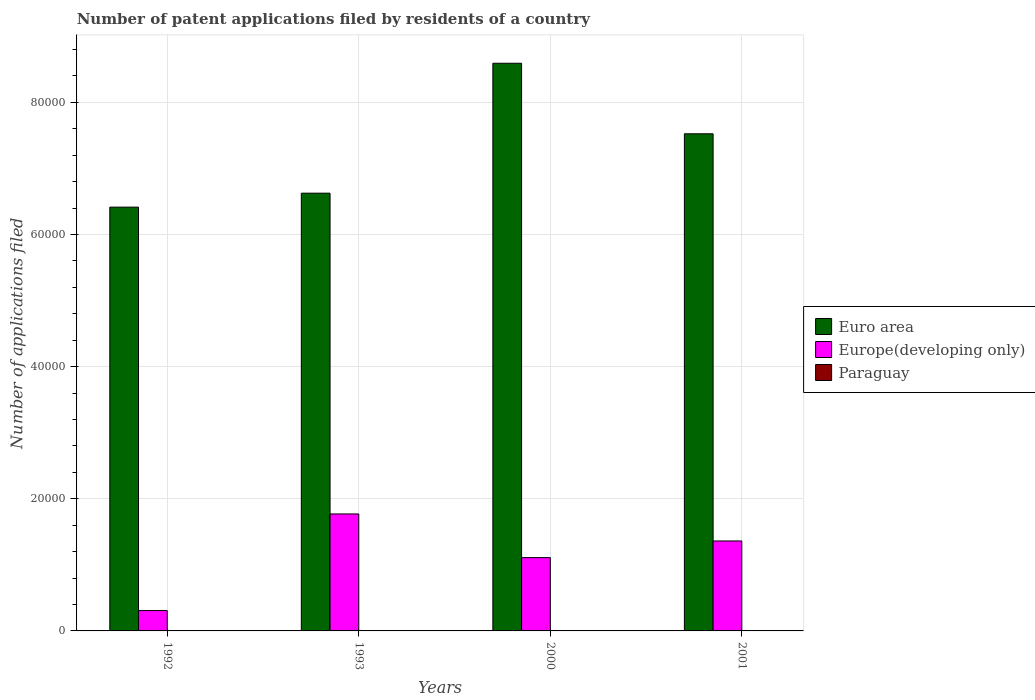How many groups of bars are there?
Offer a very short reply. 4. Are the number of bars per tick equal to the number of legend labels?
Your answer should be very brief. Yes. Are the number of bars on each tick of the X-axis equal?
Keep it short and to the point. Yes. How many bars are there on the 2nd tick from the right?
Keep it short and to the point. 3. In how many cases, is the number of bars for a given year not equal to the number of legend labels?
Keep it short and to the point. 0. Across all years, what is the maximum number of applications filed in Europe(developing only)?
Make the answer very short. 1.77e+04. Across all years, what is the minimum number of applications filed in Europe(developing only)?
Your answer should be compact. 3082. In which year was the number of applications filed in Paraguay minimum?
Provide a succinct answer. 2000. What is the total number of applications filed in Euro area in the graph?
Offer a terse response. 2.92e+05. What is the difference between the number of applications filed in Europe(developing only) in 1992 and that in 1993?
Your response must be concise. -1.46e+04. What is the difference between the number of applications filed in Paraguay in 1992 and the number of applications filed in Euro area in 2001?
Keep it short and to the point. -7.52e+04. What is the average number of applications filed in Europe(developing only) per year?
Your answer should be compact. 1.14e+04. In the year 2000, what is the difference between the number of applications filed in Europe(developing only) and number of applications filed in Paraguay?
Give a very brief answer. 1.11e+04. In how many years, is the number of applications filed in Europe(developing only) greater than 8000?
Provide a succinct answer. 3. What is the ratio of the number of applications filed in Paraguay in 1993 to that in 2000?
Make the answer very short. 2.73. Is the difference between the number of applications filed in Europe(developing only) in 1993 and 2001 greater than the difference between the number of applications filed in Paraguay in 1993 and 2001?
Provide a short and direct response. Yes. What is the difference between the highest and the second highest number of applications filed in Euro area?
Ensure brevity in your answer.  1.07e+04. What is the difference between the highest and the lowest number of applications filed in Euro area?
Keep it short and to the point. 2.18e+04. What does the 3rd bar from the left in 1992 represents?
Make the answer very short. Paraguay. What does the 2nd bar from the right in 2001 represents?
Keep it short and to the point. Europe(developing only). Is it the case that in every year, the sum of the number of applications filed in Paraguay and number of applications filed in Euro area is greater than the number of applications filed in Europe(developing only)?
Your answer should be very brief. Yes. How many bars are there?
Your answer should be compact. 12. Are all the bars in the graph horizontal?
Ensure brevity in your answer.  No. How many years are there in the graph?
Ensure brevity in your answer.  4. What is the difference between two consecutive major ticks on the Y-axis?
Provide a succinct answer. 2.00e+04. Are the values on the major ticks of Y-axis written in scientific E-notation?
Make the answer very short. No. Does the graph contain grids?
Offer a very short reply. Yes. How are the legend labels stacked?
Offer a terse response. Vertical. What is the title of the graph?
Your response must be concise. Number of patent applications filed by residents of a country. What is the label or title of the Y-axis?
Offer a terse response. Number of applications filed. What is the Number of applications filed of Euro area in 1992?
Ensure brevity in your answer.  6.41e+04. What is the Number of applications filed in Europe(developing only) in 1992?
Keep it short and to the point. 3082. What is the Number of applications filed of Paraguay in 1992?
Your response must be concise. 20. What is the Number of applications filed in Euro area in 1993?
Your answer should be compact. 6.63e+04. What is the Number of applications filed of Europe(developing only) in 1993?
Your answer should be compact. 1.77e+04. What is the Number of applications filed of Euro area in 2000?
Provide a succinct answer. 8.59e+04. What is the Number of applications filed in Europe(developing only) in 2000?
Offer a terse response. 1.11e+04. What is the Number of applications filed of Euro area in 2001?
Offer a very short reply. 7.52e+04. What is the Number of applications filed of Europe(developing only) in 2001?
Provide a succinct answer. 1.36e+04. What is the Number of applications filed of Paraguay in 2001?
Offer a very short reply. 12. Across all years, what is the maximum Number of applications filed in Euro area?
Provide a succinct answer. 8.59e+04. Across all years, what is the maximum Number of applications filed of Europe(developing only)?
Your answer should be very brief. 1.77e+04. Across all years, what is the minimum Number of applications filed in Euro area?
Your answer should be very brief. 6.41e+04. Across all years, what is the minimum Number of applications filed of Europe(developing only)?
Your answer should be compact. 3082. What is the total Number of applications filed of Euro area in the graph?
Offer a terse response. 2.92e+05. What is the total Number of applications filed in Europe(developing only) in the graph?
Ensure brevity in your answer.  4.55e+04. What is the difference between the Number of applications filed of Euro area in 1992 and that in 1993?
Your answer should be very brief. -2111. What is the difference between the Number of applications filed of Europe(developing only) in 1992 and that in 1993?
Make the answer very short. -1.46e+04. What is the difference between the Number of applications filed in Euro area in 1992 and that in 2000?
Your response must be concise. -2.18e+04. What is the difference between the Number of applications filed of Europe(developing only) in 1992 and that in 2000?
Offer a terse response. -8015. What is the difference between the Number of applications filed in Euro area in 1992 and that in 2001?
Your answer should be very brief. -1.11e+04. What is the difference between the Number of applications filed of Europe(developing only) in 1992 and that in 2001?
Offer a terse response. -1.05e+04. What is the difference between the Number of applications filed in Euro area in 1993 and that in 2000?
Ensure brevity in your answer.  -1.97e+04. What is the difference between the Number of applications filed of Europe(developing only) in 1993 and that in 2000?
Offer a terse response. 6608. What is the difference between the Number of applications filed in Euro area in 1993 and that in 2001?
Your response must be concise. -8989. What is the difference between the Number of applications filed of Europe(developing only) in 1993 and that in 2001?
Your answer should be compact. 4090. What is the difference between the Number of applications filed in Euro area in 2000 and that in 2001?
Offer a terse response. 1.07e+04. What is the difference between the Number of applications filed of Europe(developing only) in 2000 and that in 2001?
Your response must be concise. -2518. What is the difference between the Number of applications filed of Paraguay in 2000 and that in 2001?
Give a very brief answer. -1. What is the difference between the Number of applications filed in Euro area in 1992 and the Number of applications filed in Europe(developing only) in 1993?
Provide a succinct answer. 4.64e+04. What is the difference between the Number of applications filed of Euro area in 1992 and the Number of applications filed of Paraguay in 1993?
Your answer should be very brief. 6.41e+04. What is the difference between the Number of applications filed in Europe(developing only) in 1992 and the Number of applications filed in Paraguay in 1993?
Provide a succinct answer. 3052. What is the difference between the Number of applications filed in Euro area in 1992 and the Number of applications filed in Europe(developing only) in 2000?
Offer a very short reply. 5.30e+04. What is the difference between the Number of applications filed in Euro area in 1992 and the Number of applications filed in Paraguay in 2000?
Your response must be concise. 6.41e+04. What is the difference between the Number of applications filed of Europe(developing only) in 1992 and the Number of applications filed of Paraguay in 2000?
Your answer should be compact. 3071. What is the difference between the Number of applications filed in Euro area in 1992 and the Number of applications filed in Europe(developing only) in 2001?
Give a very brief answer. 5.05e+04. What is the difference between the Number of applications filed in Euro area in 1992 and the Number of applications filed in Paraguay in 2001?
Your answer should be very brief. 6.41e+04. What is the difference between the Number of applications filed in Europe(developing only) in 1992 and the Number of applications filed in Paraguay in 2001?
Keep it short and to the point. 3070. What is the difference between the Number of applications filed of Euro area in 1993 and the Number of applications filed of Europe(developing only) in 2000?
Provide a succinct answer. 5.52e+04. What is the difference between the Number of applications filed of Euro area in 1993 and the Number of applications filed of Paraguay in 2000?
Provide a succinct answer. 6.62e+04. What is the difference between the Number of applications filed in Europe(developing only) in 1993 and the Number of applications filed in Paraguay in 2000?
Your response must be concise. 1.77e+04. What is the difference between the Number of applications filed in Euro area in 1993 and the Number of applications filed in Europe(developing only) in 2001?
Offer a terse response. 5.26e+04. What is the difference between the Number of applications filed of Euro area in 1993 and the Number of applications filed of Paraguay in 2001?
Provide a short and direct response. 6.62e+04. What is the difference between the Number of applications filed in Europe(developing only) in 1993 and the Number of applications filed in Paraguay in 2001?
Make the answer very short. 1.77e+04. What is the difference between the Number of applications filed of Euro area in 2000 and the Number of applications filed of Europe(developing only) in 2001?
Offer a very short reply. 7.23e+04. What is the difference between the Number of applications filed in Euro area in 2000 and the Number of applications filed in Paraguay in 2001?
Keep it short and to the point. 8.59e+04. What is the difference between the Number of applications filed of Europe(developing only) in 2000 and the Number of applications filed of Paraguay in 2001?
Your response must be concise. 1.11e+04. What is the average Number of applications filed of Euro area per year?
Provide a short and direct response. 7.29e+04. What is the average Number of applications filed of Europe(developing only) per year?
Offer a terse response. 1.14e+04. What is the average Number of applications filed in Paraguay per year?
Your response must be concise. 18.25. In the year 1992, what is the difference between the Number of applications filed of Euro area and Number of applications filed of Europe(developing only)?
Provide a succinct answer. 6.11e+04. In the year 1992, what is the difference between the Number of applications filed in Euro area and Number of applications filed in Paraguay?
Provide a succinct answer. 6.41e+04. In the year 1992, what is the difference between the Number of applications filed of Europe(developing only) and Number of applications filed of Paraguay?
Offer a terse response. 3062. In the year 1993, what is the difference between the Number of applications filed of Euro area and Number of applications filed of Europe(developing only)?
Ensure brevity in your answer.  4.85e+04. In the year 1993, what is the difference between the Number of applications filed in Euro area and Number of applications filed in Paraguay?
Offer a very short reply. 6.62e+04. In the year 1993, what is the difference between the Number of applications filed in Europe(developing only) and Number of applications filed in Paraguay?
Keep it short and to the point. 1.77e+04. In the year 2000, what is the difference between the Number of applications filed in Euro area and Number of applications filed in Europe(developing only)?
Your answer should be compact. 7.48e+04. In the year 2000, what is the difference between the Number of applications filed in Euro area and Number of applications filed in Paraguay?
Offer a very short reply. 8.59e+04. In the year 2000, what is the difference between the Number of applications filed of Europe(developing only) and Number of applications filed of Paraguay?
Provide a short and direct response. 1.11e+04. In the year 2001, what is the difference between the Number of applications filed in Euro area and Number of applications filed in Europe(developing only)?
Keep it short and to the point. 6.16e+04. In the year 2001, what is the difference between the Number of applications filed of Euro area and Number of applications filed of Paraguay?
Offer a terse response. 7.52e+04. In the year 2001, what is the difference between the Number of applications filed in Europe(developing only) and Number of applications filed in Paraguay?
Provide a short and direct response. 1.36e+04. What is the ratio of the Number of applications filed in Euro area in 1992 to that in 1993?
Your answer should be very brief. 0.97. What is the ratio of the Number of applications filed in Europe(developing only) in 1992 to that in 1993?
Ensure brevity in your answer.  0.17. What is the ratio of the Number of applications filed in Euro area in 1992 to that in 2000?
Provide a succinct answer. 0.75. What is the ratio of the Number of applications filed in Europe(developing only) in 1992 to that in 2000?
Offer a very short reply. 0.28. What is the ratio of the Number of applications filed of Paraguay in 1992 to that in 2000?
Your answer should be very brief. 1.82. What is the ratio of the Number of applications filed of Euro area in 1992 to that in 2001?
Offer a very short reply. 0.85. What is the ratio of the Number of applications filed of Europe(developing only) in 1992 to that in 2001?
Ensure brevity in your answer.  0.23. What is the ratio of the Number of applications filed in Paraguay in 1992 to that in 2001?
Give a very brief answer. 1.67. What is the ratio of the Number of applications filed of Euro area in 1993 to that in 2000?
Your answer should be compact. 0.77. What is the ratio of the Number of applications filed of Europe(developing only) in 1993 to that in 2000?
Make the answer very short. 1.6. What is the ratio of the Number of applications filed of Paraguay in 1993 to that in 2000?
Your answer should be compact. 2.73. What is the ratio of the Number of applications filed in Euro area in 1993 to that in 2001?
Offer a terse response. 0.88. What is the ratio of the Number of applications filed in Europe(developing only) in 1993 to that in 2001?
Give a very brief answer. 1.3. What is the ratio of the Number of applications filed in Euro area in 2000 to that in 2001?
Your answer should be very brief. 1.14. What is the ratio of the Number of applications filed in Europe(developing only) in 2000 to that in 2001?
Offer a terse response. 0.82. What is the ratio of the Number of applications filed of Paraguay in 2000 to that in 2001?
Offer a terse response. 0.92. What is the difference between the highest and the second highest Number of applications filed of Euro area?
Offer a very short reply. 1.07e+04. What is the difference between the highest and the second highest Number of applications filed in Europe(developing only)?
Ensure brevity in your answer.  4090. What is the difference between the highest and the second highest Number of applications filed of Paraguay?
Provide a short and direct response. 10. What is the difference between the highest and the lowest Number of applications filed of Euro area?
Make the answer very short. 2.18e+04. What is the difference between the highest and the lowest Number of applications filed in Europe(developing only)?
Keep it short and to the point. 1.46e+04. 